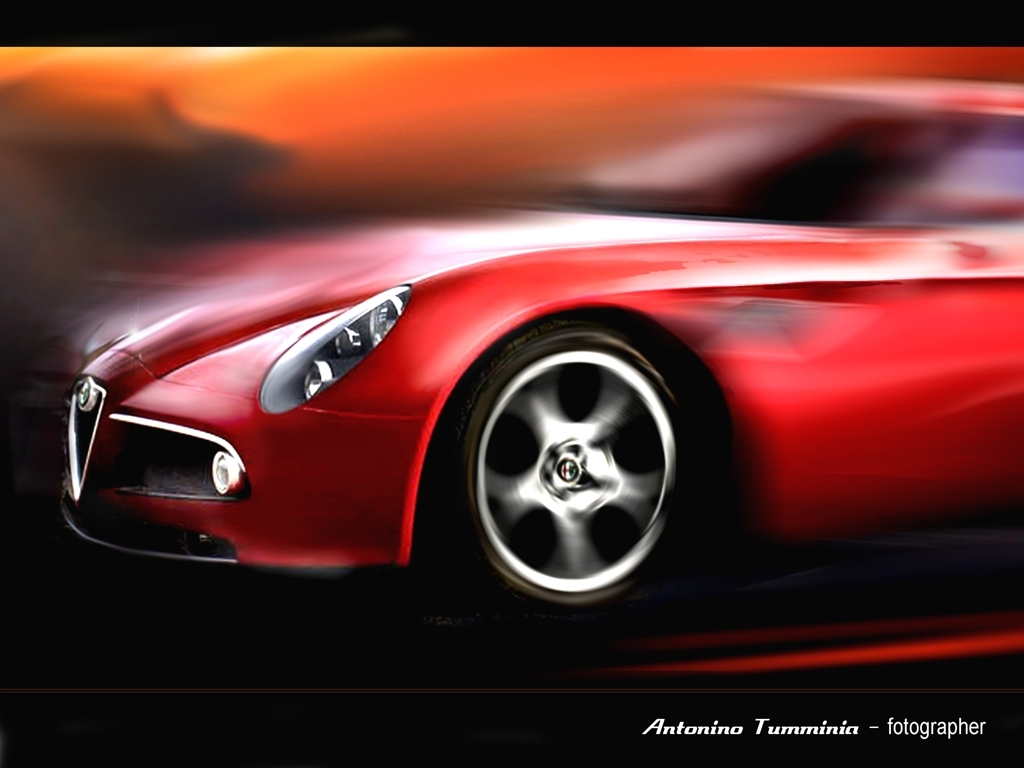What is the overall clarity of the image? The image appears to be intentionally blurred to give a sense of motion, specifically around the wheels and background, while preserving some sharpness at the front, highlighting the car's grille and headlights. 